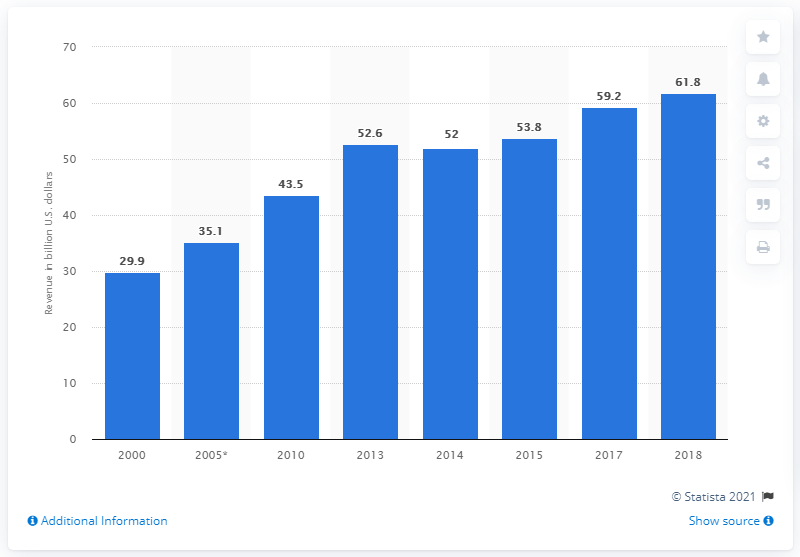Outline some significant characteristics in this image. In 2018, the water utility industry generated a total revenue of 61.8 billion U.S. dollars. 